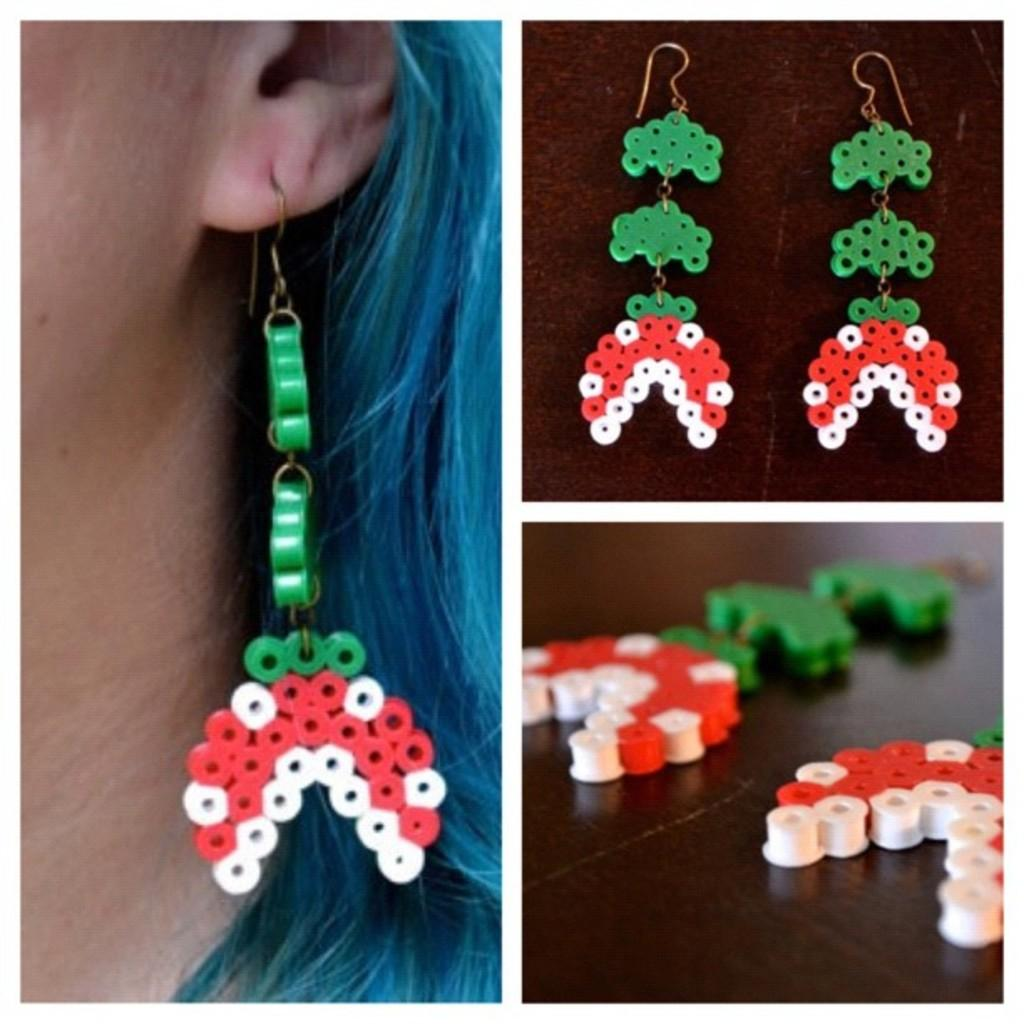What type of image is shown in the collage? The image is a collage. How many pictures are included in the collage? There are three pictures in the collage. What is the common subject of all three pictures? All three pictures show the same earrings. Can you describe the content of one of the pictures? In one of the pictures, a person is wearing the earrings. What type of suit is the person wearing in the image? There is no suit visible in the image; the focus is on the earrings. Can you describe the art style used in the collage? The provided facts do not mention the art style used in the collage. --- Facts: 1. There is a person sitting on a chair in the image. 2. The person is holding a book. 3. The book has a blue cover. 4. The chair is made of wood. 5. There is a window behind the person. Absurd Topics: parrot, ocean, bicycle Conversation: What is the person in the image doing? The person is sitting on a chair in the image. What object is the person holding? The person is holding a book. What color is the book's cover? The book has a blue cover. What material is the chair made of? The chair is made of wood. What can be seen behind the person? There is a window behind the person. Reasoning: Let's think step by step in order to produce the conversation. We start by identifying the main subject in the image, which is the person sitting on a chair. Then, we expand the conversation to include other items that are also visible, such as the book, the book's cover color, the chair's material, and the window behind the person. Each question is designed to elicit a specific detail about the image that is known from the provided facts. Absurd Question/Answer: Can you describe the parrot sitting on the person's shoulder in the image? There is no parrot present in the image; the person is holding a book. What type of ocean can be seen through the window in the image? There is no ocean visible in the image; only a window is mentioned. 